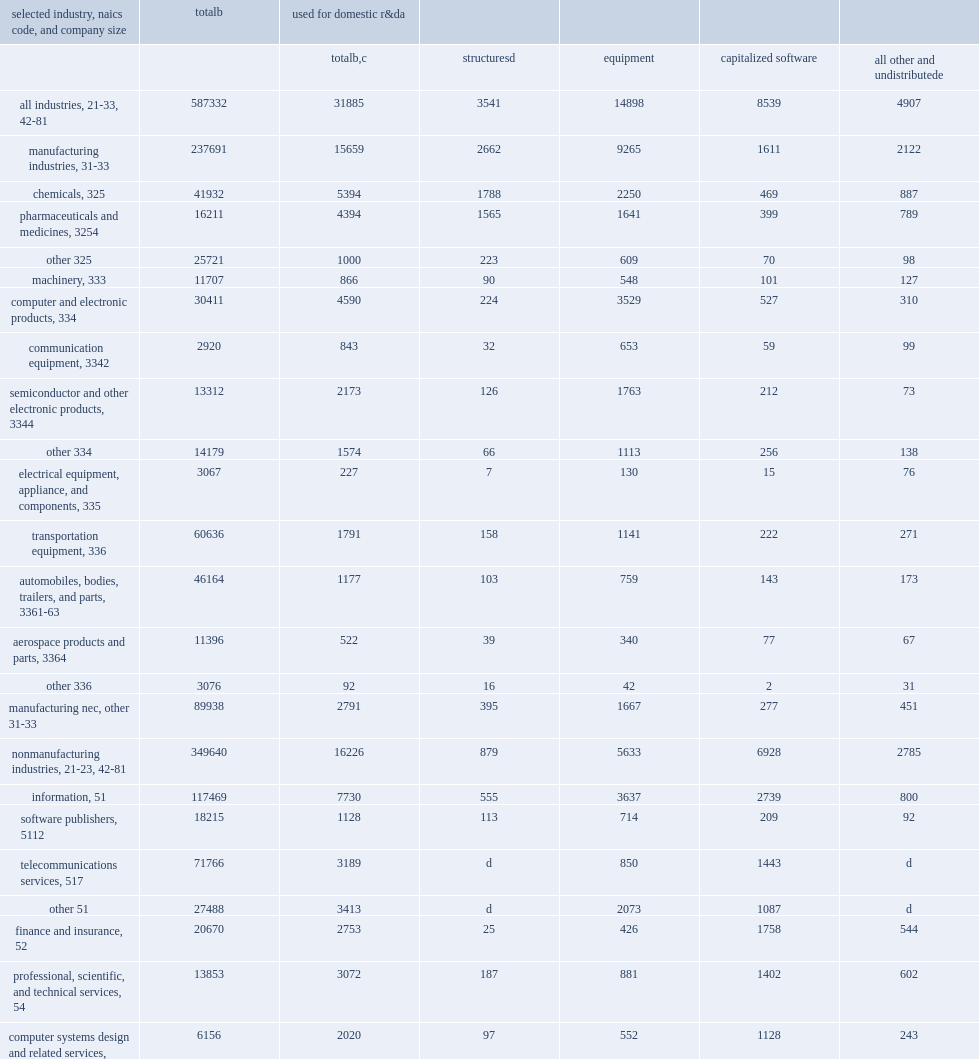How many million dollars did companies that performed or funded r&d in the united states in 2017 spend on assets with expected useful lives of more than 1 year? 587332.0. How many million dollars were spent on structures, equipment, software, and other assets used for r&d? 31885.0. How many million dollars by manufacturing industries were spent on structures, equipment, software, and other assets used for r&d? 15659.0. How many million dollars by nonmanufacturing industries were spent on structures, equipment, software, and other assets used for r&d? 16226.0. 